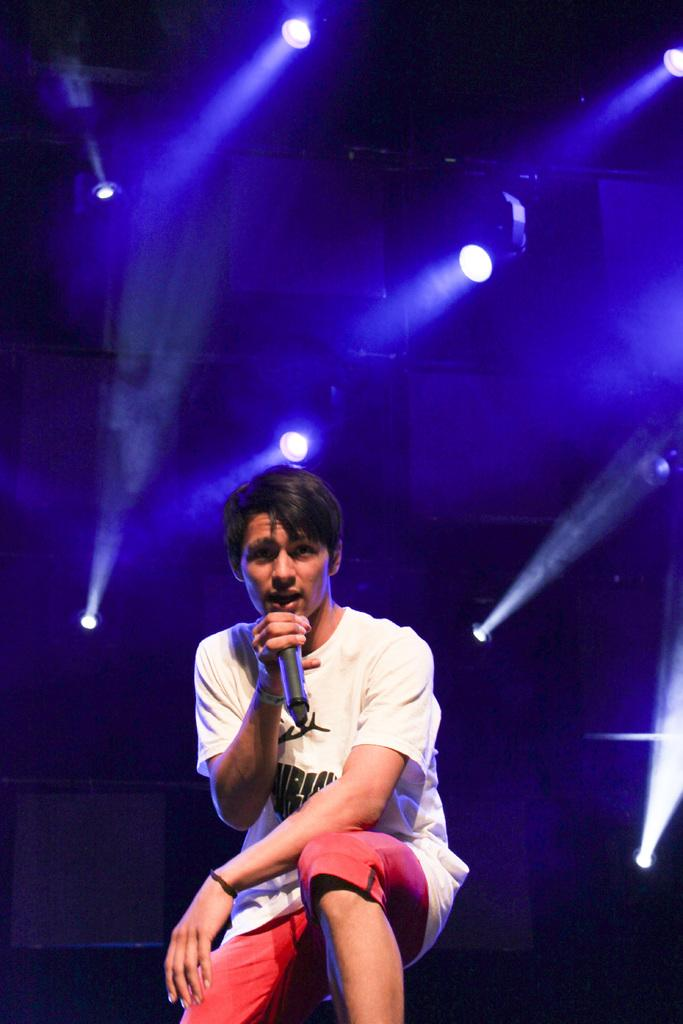What is the main subject of the image? There is a person in the image. What is the person holding in the image? The person is holding a mic. What can be seen in the background of the image? There are lights visible in the background of the image. What type of pet can be seen playing with a brick in the image? There is no pet or brick present in the image; it features a person holding a mic. 